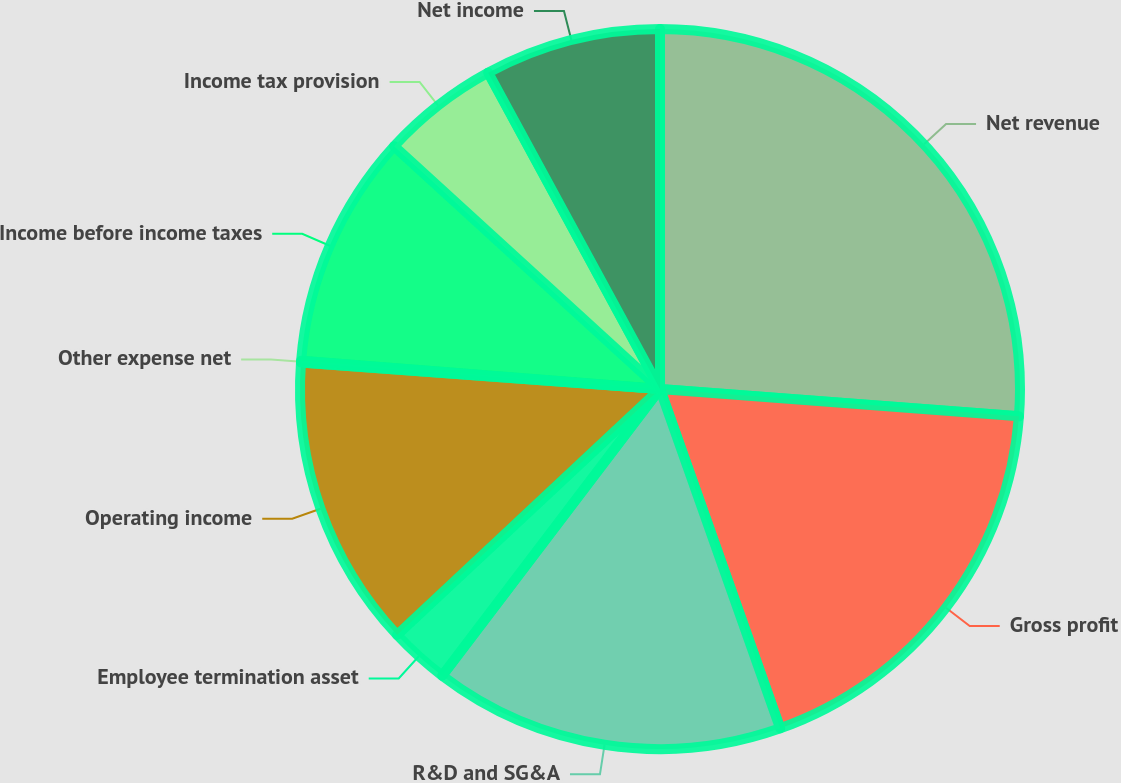Convert chart to OTSL. <chart><loc_0><loc_0><loc_500><loc_500><pie_chart><fcel>Net revenue<fcel>Gross profit<fcel>R&D and SG&A<fcel>Employee termination asset<fcel>Operating income<fcel>Other expense net<fcel>Income before income taxes<fcel>Income tax provision<fcel>Net income<nl><fcel>26.21%<fcel>18.37%<fcel>15.76%<fcel>2.69%<fcel>13.14%<fcel>0.08%<fcel>10.53%<fcel>5.3%<fcel>7.92%<nl></chart> 